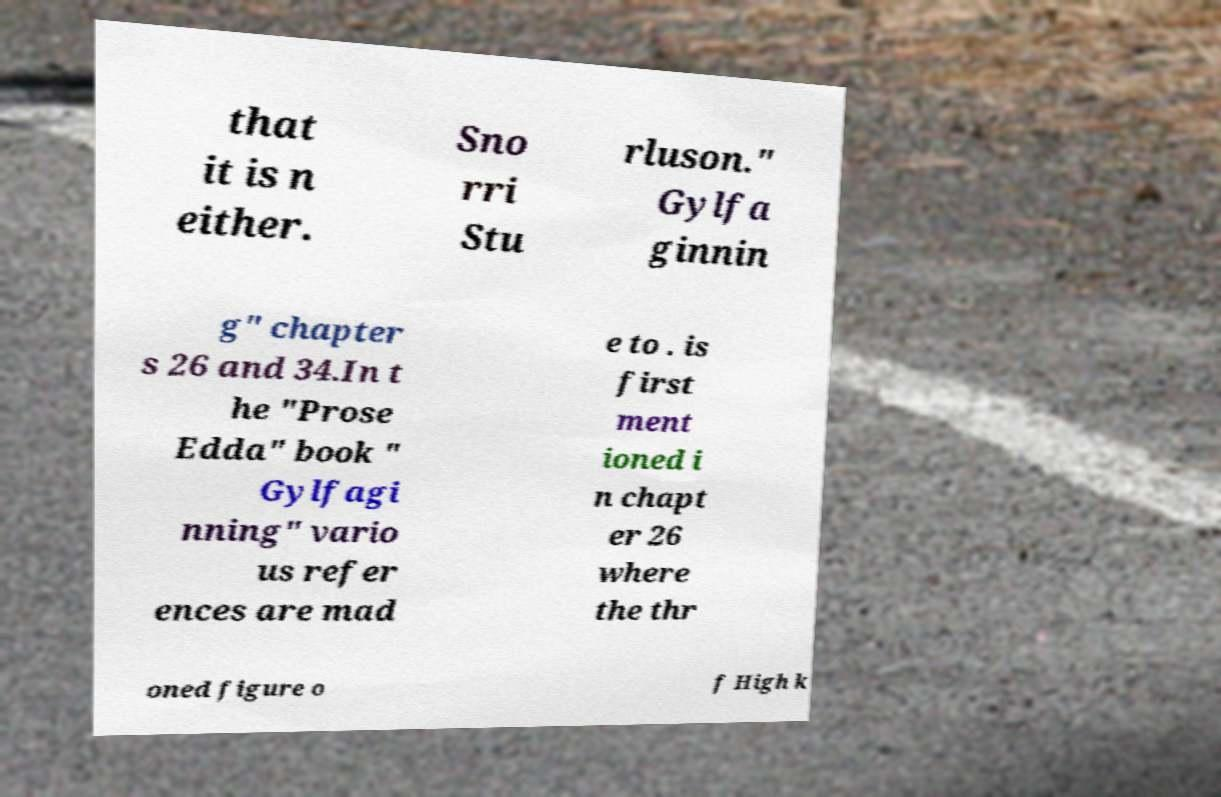Could you extract and type out the text from this image? that it is n either. Sno rri Stu rluson." Gylfa ginnin g" chapter s 26 and 34.In t he "Prose Edda" book " Gylfagi nning" vario us refer ences are mad e to . is first ment ioned i n chapt er 26 where the thr oned figure o f High k 